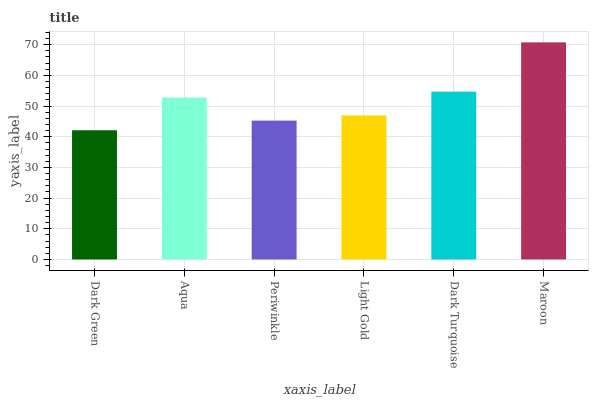Is Aqua the minimum?
Answer yes or no. No. Is Aqua the maximum?
Answer yes or no. No. Is Aqua greater than Dark Green?
Answer yes or no. Yes. Is Dark Green less than Aqua?
Answer yes or no. Yes. Is Dark Green greater than Aqua?
Answer yes or no. No. Is Aqua less than Dark Green?
Answer yes or no. No. Is Aqua the high median?
Answer yes or no. Yes. Is Light Gold the low median?
Answer yes or no. Yes. Is Maroon the high median?
Answer yes or no. No. Is Maroon the low median?
Answer yes or no. No. 